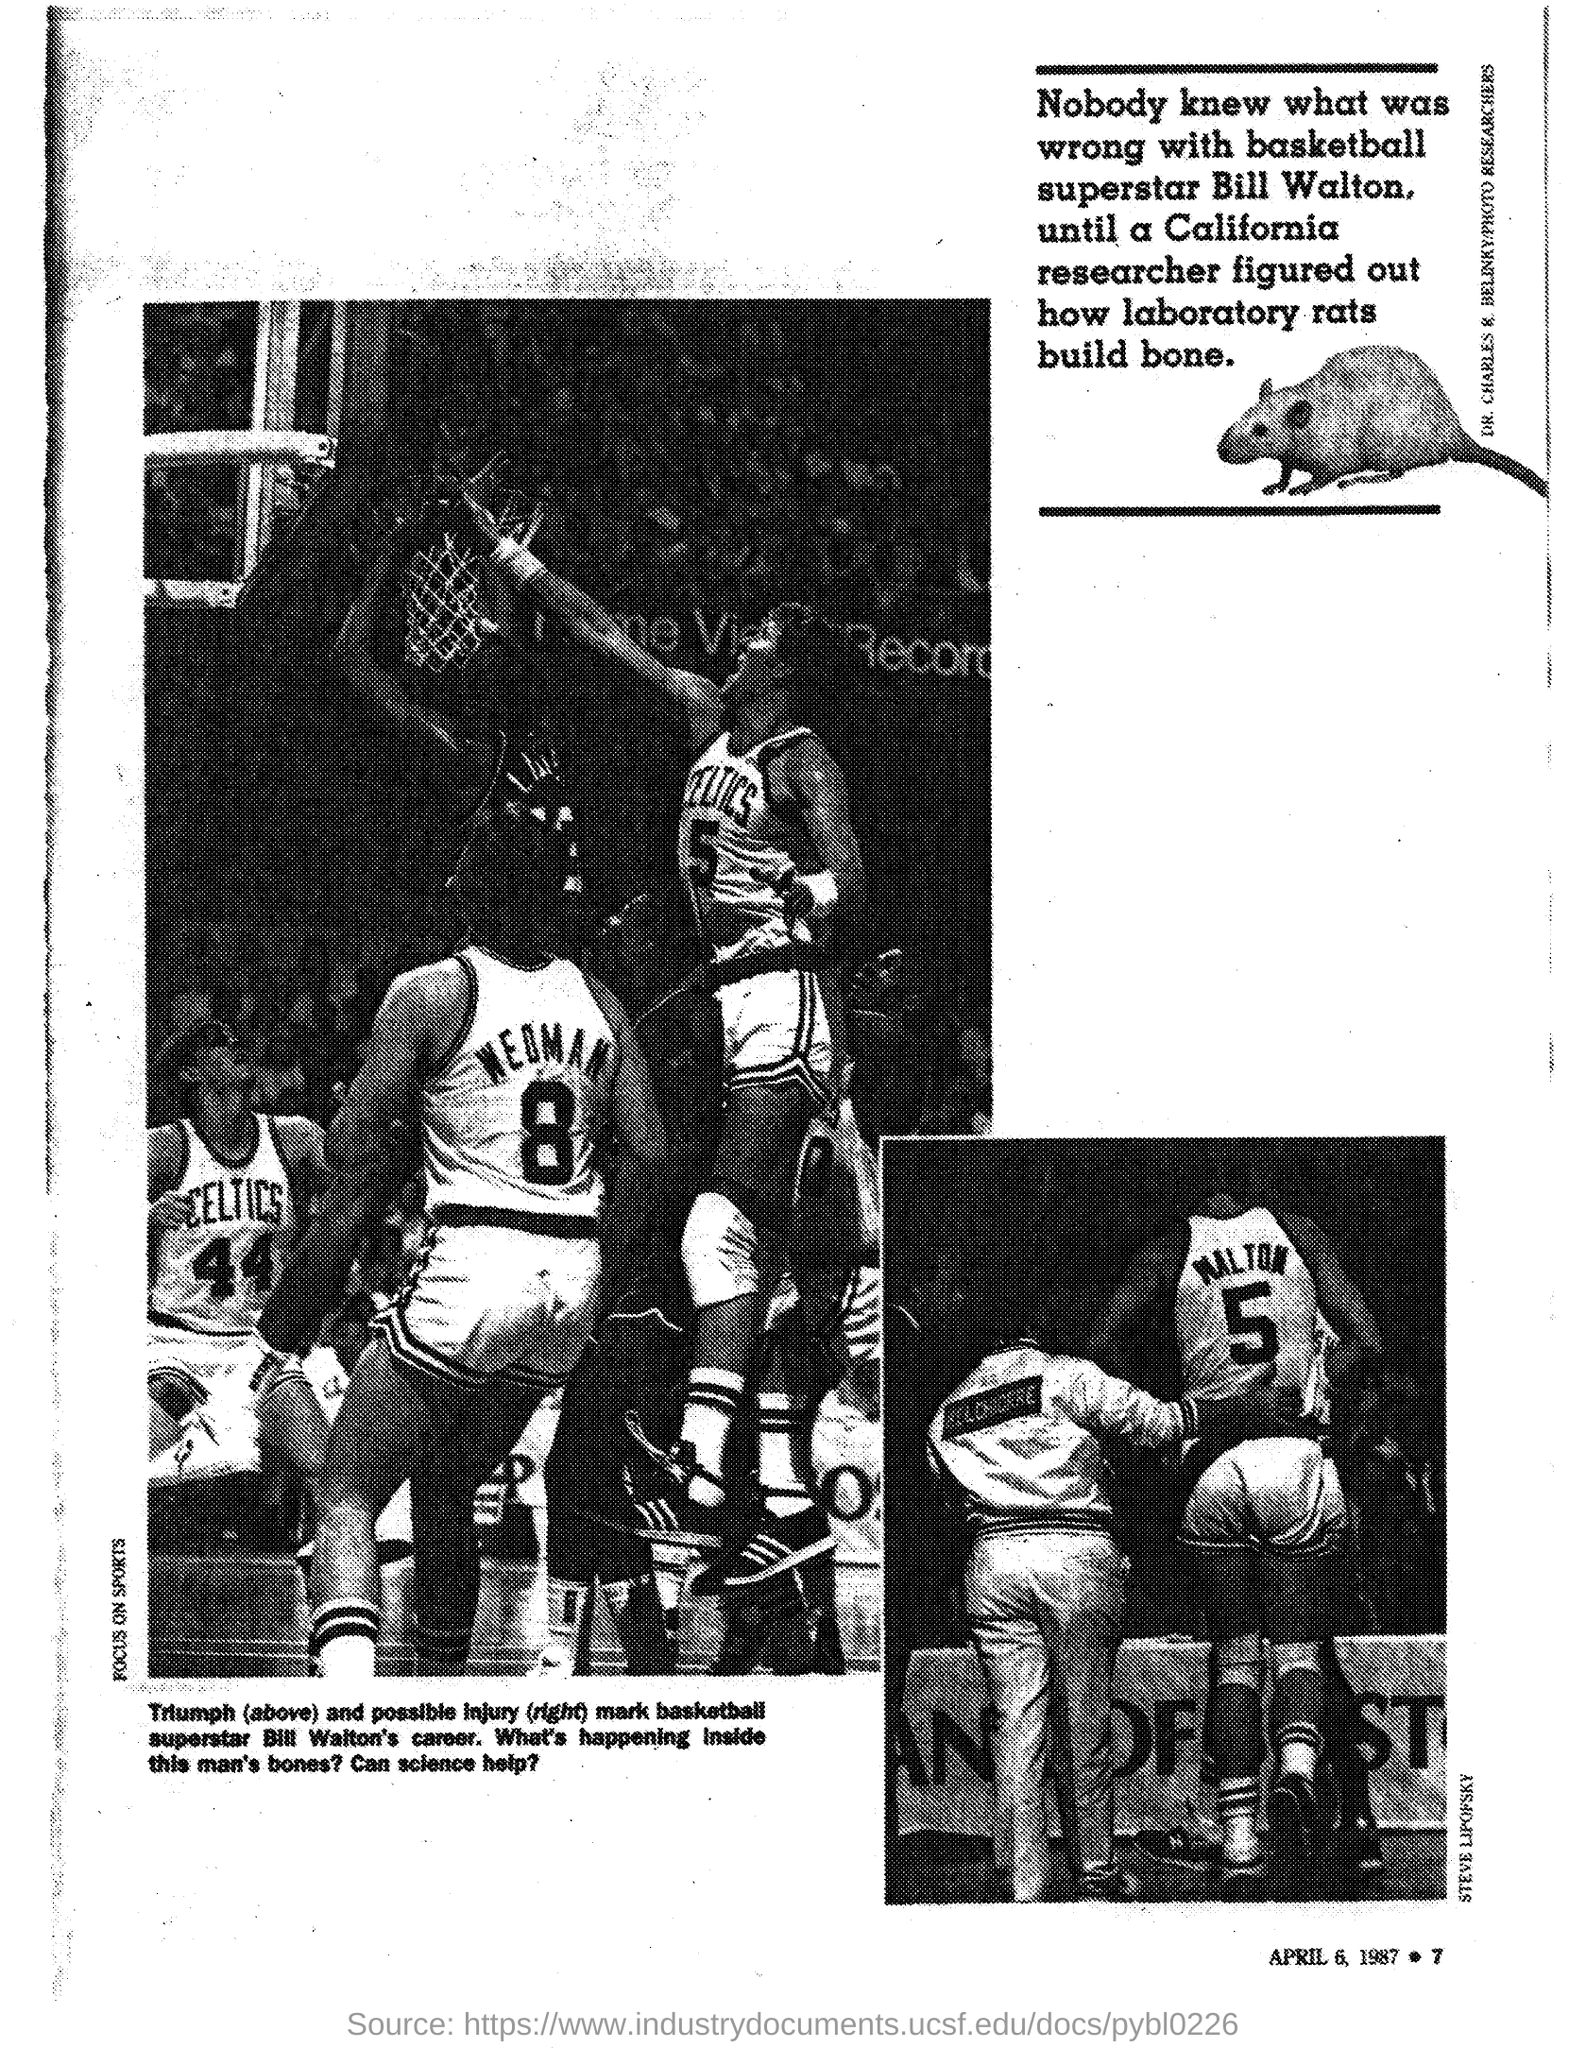Who is the basketball superstar mentioned in the document?
Offer a terse response. BILL WALTON. 